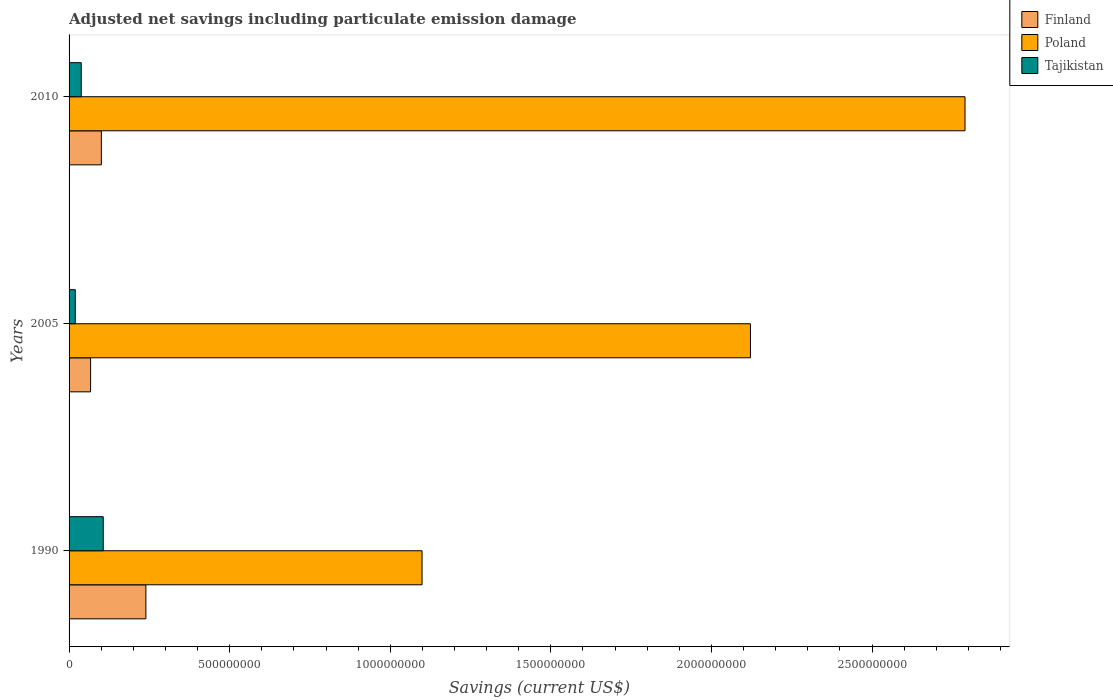How many different coloured bars are there?
Offer a terse response. 3. How many bars are there on the 1st tick from the top?
Your response must be concise. 3. What is the label of the 1st group of bars from the top?
Ensure brevity in your answer.  2010. In how many cases, is the number of bars for a given year not equal to the number of legend labels?
Provide a short and direct response. 0. What is the net savings in Poland in 2005?
Provide a succinct answer. 2.12e+09. Across all years, what is the maximum net savings in Finland?
Your answer should be very brief. 2.39e+08. Across all years, what is the minimum net savings in Poland?
Your answer should be compact. 1.10e+09. In which year was the net savings in Tajikistan maximum?
Make the answer very short. 1990. What is the total net savings in Poland in the graph?
Give a very brief answer. 6.01e+09. What is the difference between the net savings in Poland in 1990 and that in 2005?
Your response must be concise. -1.02e+09. What is the difference between the net savings in Finland in 1990 and the net savings in Tajikistan in 2010?
Ensure brevity in your answer.  2.01e+08. What is the average net savings in Poland per year?
Offer a very short reply. 2.00e+09. In the year 1990, what is the difference between the net savings in Finland and net savings in Poland?
Your response must be concise. -8.60e+08. In how many years, is the net savings in Tajikistan greater than 300000000 US$?
Offer a terse response. 0. What is the ratio of the net savings in Poland in 1990 to that in 2005?
Ensure brevity in your answer.  0.52. Is the difference between the net savings in Finland in 2005 and 2010 greater than the difference between the net savings in Poland in 2005 and 2010?
Offer a very short reply. Yes. What is the difference between the highest and the second highest net savings in Tajikistan?
Your answer should be very brief. 6.86e+07. What is the difference between the highest and the lowest net savings in Finland?
Provide a succinct answer. 1.72e+08. What does the 2nd bar from the bottom in 2005 represents?
Offer a terse response. Poland. Is it the case that in every year, the sum of the net savings in Tajikistan and net savings in Finland is greater than the net savings in Poland?
Make the answer very short. No. How many bars are there?
Make the answer very short. 9. What is the difference between two consecutive major ticks on the X-axis?
Ensure brevity in your answer.  5.00e+08. Are the values on the major ticks of X-axis written in scientific E-notation?
Provide a succinct answer. No. Does the graph contain any zero values?
Your response must be concise. No. Does the graph contain grids?
Give a very brief answer. No. Where does the legend appear in the graph?
Give a very brief answer. Top right. How are the legend labels stacked?
Give a very brief answer. Vertical. What is the title of the graph?
Your response must be concise. Adjusted net savings including particulate emission damage. What is the label or title of the X-axis?
Give a very brief answer. Savings (current US$). What is the label or title of the Y-axis?
Your answer should be very brief. Years. What is the Savings (current US$) in Finland in 1990?
Provide a short and direct response. 2.39e+08. What is the Savings (current US$) of Poland in 1990?
Provide a succinct answer. 1.10e+09. What is the Savings (current US$) in Tajikistan in 1990?
Your answer should be very brief. 1.06e+08. What is the Savings (current US$) in Finland in 2005?
Your response must be concise. 6.70e+07. What is the Savings (current US$) in Poland in 2005?
Offer a very short reply. 2.12e+09. What is the Savings (current US$) of Tajikistan in 2005?
Offer a very short reply. 1.93e+07. What is the Savings (current US$) of Finland in 2010?
Offer a terse response. 1.01e+08. What is the Savings (current US$) in Poland in 2010?
Make the answer very short. 2.79e+09. What is the Savings (current US$) of Tajikistan in 2010?
Keep it short and to the point. 3.79e+07. Across all years, what is the maximum Savings (current US$) of Finland?
Provide a short and direct response. 2.39e+08. Across all years, what is the maximum Savings (current US$) in Poland?
Ensure brevity in your answer.  2.79e+09. Across all years, what is the maximum Savings (current US$) of Tajikistan?
Ensure brevity in your answer.  1.06e+08. Across all years, what is the minimum Savings (current US$) of Finland?
Your answer should be compact. 6.70e+07. Across all years, what is the minimum Savings (current US$) in Poland?
Provide a short and direct response. 1.10e+09. Across all years, what is the minimum Savings (current US$) in Tajikistan?
Your answer should be very brief. 1.93e+07. What is the total Savings (current US$) in Finland in the graph?
Your answer should be very brief. 4.07e+08. What is the total Savings (current US$) in Poland in the graph?
Provide a short and direct response. 6.01e+09. What is the total Savings (current US$) of Tajikistan in the graph?
Ensure brevity in your answer.  1.64e+08. What is the difference between the Savings (current US$) in Finland in 1990 and that in 2005?
Your answer should be very brief. 1.72e+08. What is the difference between the Savings (current US$) of Poland in 1990 and that in 2005?
Your answer should be compact. -1.02e+09. What is the difference between the Savings (current US$) of Tajikistan in 1990 and that in 2005?
Provide a short and direct response. 8.71e+07. What is the difference between the Savings (current US$) in Finland in 1990 and that in 2010?
Offer a terse response. 1.39e+08. What is the difference between the Savings (current US$) in Poland in 1990 and that in 2010?
Give a very brief answer. -1.69e+09. What is the difference between the Savings (current US$) in Tajikistan in 1990 and that in 2010?
Ensure brevity in your answer.  6.86e+07. What is the difference between the Savings (current US$) of Finland in 2005 and that in 2010?
Provide a succinct answer. -3.35e+07. What is the difference between the Savings (current US$) in Poland in 2005 and that in 2010?
Your answer should be compact. -6.68e+08. What is the difference between the Savings (current US$) in Tajikistan in 2005 and that in 2010?
Your answer should be very brief. -1.86e+07. What is the difference between the Savings (current US$) of Finland in 1990 and the Savings (current US$) of Poland in 2005?
Give a very brief answer. -1.88e+09. What is the difference between the Savings (current US$) in Finland in 1990 and the Savings (current US$) in Tajikistan in 2005?
Offer a terse response. 2.20e+08. What is the difference between the Savings (current US$) of Poland in 1990 and the Savings (current US$) of Tajikistan in 2005?
Ensure brevity in your answer.  1.08e+09. What is the difference between the Savings (current US$) of Finland in 1990 and the Savings (current US$) of Poland in 2010?
Offer a very short reply. -2.55e+09. What is the difference between the Savings (current US$) in Finland in 1990 and the Savings (current US$) in Tajikistan in 2010?
Your answer should be very brief. 2.01e+08. What is the difference between the Savings (current US$) of Poland in 1990 and the Savings (current US$) of Tajikistan in 2010?
Give a very brief answer. 1.06e+09. What is the difference between the Savings (current US$) of Finland in 2005 and the Savings (current US$) of Poland in 2010?
Give a very brief answer. -2.72e+09. What is the difference between the Savings (current US$) in Finland in 2005 and the Savings (current US$) in Tajikistan in 2010?
Keep it short and to the point. 2.92e+07. What is the difference between the Savings (current US$) of Poland in 2005 and the Savings (current US$) of Tajikistan in 2010?
Your answer should be compact. 2.08e+09. What is the average Savings (current US$) of Finland per year?
Your answer should be very brief. 1.36e+08. What is the average Savings (current US$) of Poland per year?
Make the answer very short. 2.00e+09. What is the average Savings (current US$) in Tajikistan per year?
Make the answer very short. 5.45e+07. In the year 1990, what is the difference between the Savings (current US$) of Finland and Savings (current US$) of Poland?
Your answer should be compact. -8.60e+08. In the year 1990, what is the difference between the Savings (current US$) of Finland and Savings (current US$) of Tajikistan?
Provide a short and direct response. 1.33e+08. In the year 1990, what is the difference between the Savings (current US$) of Poland and Savings (current US$) of Tajikistan?
Your response must be concise. 9.93e+08. In the year 2005, what is the difference between the Savings (current US$) of Finland and Savings (current US$) of Poland?
Offer a terse response. -2.05e+09. In the year 2005, what is the difference between the Savings (current US$) in Finland and Savings (current US$) in Tajikistan?
Keep it short and to the point. 4.77e+07. In the year 2005, what is the difference between the Savings (current US$) of Poland and Savings (current US$) of Tajikistan?
Provide a short and direct response. 2.10e+09. In the year 2010, what is the difference between the Savings (current US$) of Finland and Savings (current US$) of Poland?
Keep it short and to the point. -2.69e+09. In the year 2010, what is the difference between the Savings (current US$) of Finland and Savings (current US$) of Tajikistan?
Your response must be concise. 6.26e+07. In the year 2010, what is the difference between the Savings (current US$) in Poland and Savings (current US$) in Tajikistan?
Make the answer very short. 2.75e+09. What is the ratio of the Savings (current US$) in Finland in 1990 to that in 2005?
Keep it short and to the point. 3.57. What is the ratio of the Savings (current US$) in Poland in 1990 to that in 2005?
Make the answer very short. 0.52. What is the ratio of the Savings (current US$) of Tajikistan in 1990 to that in 2005?
Keep it short and to the point. 5.52. What is the ratio of the Savings (current US$) of Finland in 1990 to that in 2010?
Provide a succinct answer. 2.38. What is the ratio of the Savings (current US$) of Poland in 1990 to that in 2010?
Keep it short and to the point. 0.39. What is the ratio of the Savings (current US$) in Tajikistan in 1990 to that in 2010?
Give a very brief answer. 2.81. What is the ratio of the Savings (current US$) of Finland in 2005 to that in 2010?
Offer a very short reply. 0.67. What is the ratio of the Savings (current US$) of Poland in 2005 to that in 2010?
Give a very brief answer. 0.76. What is the ratio of the Savings (current US$) in Tajikistan in 2005 to that in 2010?
Offer a very short reply. 0.51. What is the difference between the highest and the second highest Savings (current US$) in Finland?
Your answer should be compact. 1.39e+08. What is the difference between the highest and the second highest Savings (current US$) in Poland?
Provide a short and direct response. 6.68e+08. What is the difference between the highest and the second highest Savings (current US$) in Tajikistan?
Give a very brief answer. 6.86e+07. What is the difference between the highest and the lowest Savings (current US$) of Finland?
Make the answer very short. 1.72e+08. What is the difference between the highest and the lowest Savings (current US$) of Poland?
Offer a very short reply. 1.69e+09. What is the difference between the highest and the lowest Savings (current US$) in Tajikistan?
Make the answer very short. 8.71e+07. 